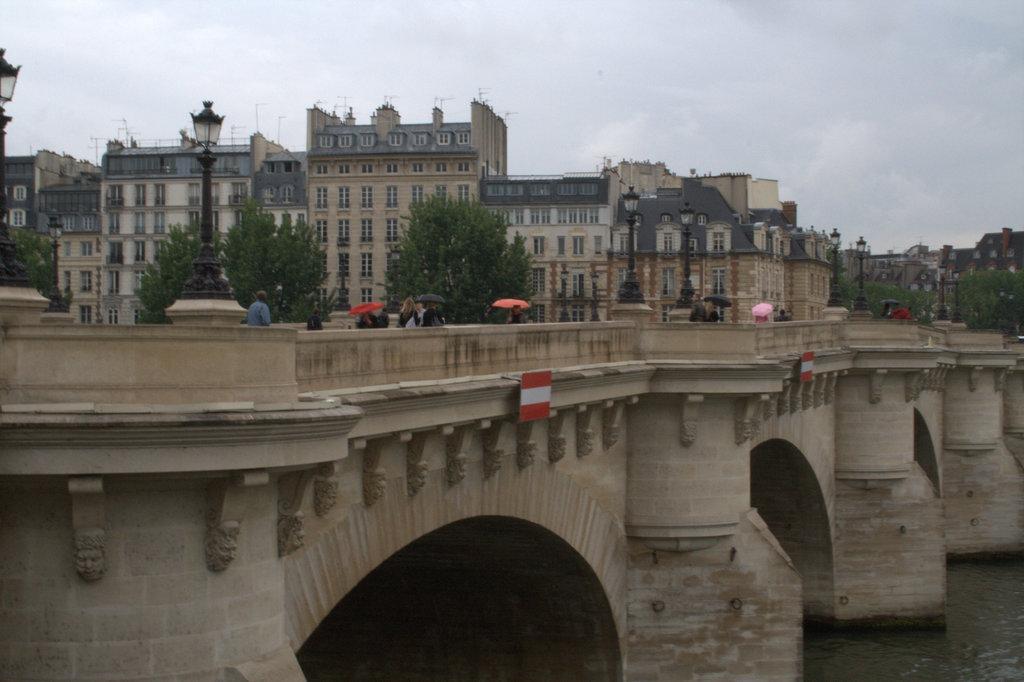Please provide a concise description of this image. In the foreground of the picture there are people on the bridge and water. In the center of the picture there are trees, street lights and buildings. Sky is cloudy. 